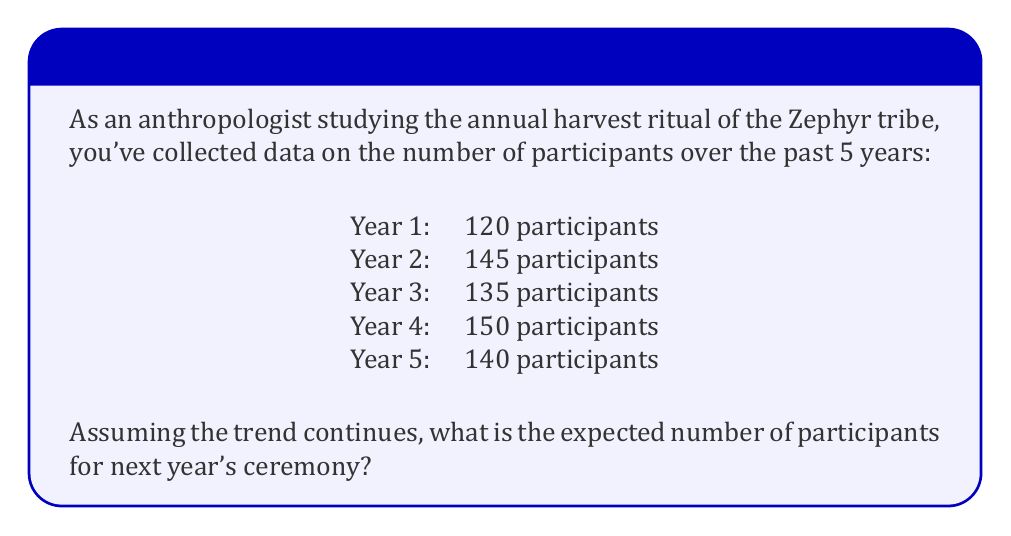Give your solution to this math problem. To estimate the expected number of participants for next year's ceremony, we'll use the concept of expected value based on historical data. Here's how we can approach this problem:

1. Calculate the average (mean) number of participants over the past 5 years:

   $$\text{Average} = \frac{\sum_{i=1}^{5} \text{Participants}_i}{5}$$

   $$= \frac{120 + 145 + 135 + 150 + 140}{5}$$

   $$= \frac{690}{5} = 138$$

2. Assuming the trend continues, the expected number of participants for next year would be equal to this average.

3. We can also calculate the variance to understand the spread of the data:

   $$\text{Variance} = \frac{\sum_{i=1}^{5} (\text{Participants}_i - \text{Average})^2}{5}$$

   $$= \frac{(120-138)^2 + (145-138)^2 + (135-138)^2 + (150-138)^2 + (140-138)^2}{5}$$

   $$= \frac{324 + 49 + 9 + 144 + 4}{5} = 106$$

4. The standard deviation is the square root of the variance:

   $$\text{Standard Deviation} = \sqrt{106} \approx 10.3$$

This means that while we expect about 138 participants, the actual number could typically vary by about 10 participants in either direction.

Therefore, based on the historical data, the expected number of participants for next year's ceremony is 138.
Answer: 138 participants 